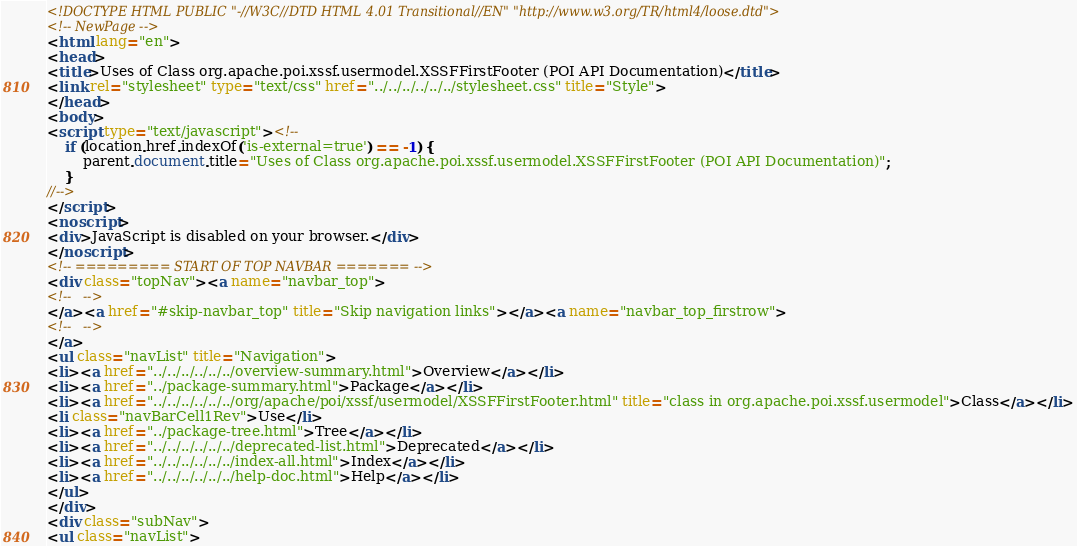<code> <loc_0><loc_0><loc_500><loc_500><_HTML_><!DOCTYPE HTML PUBLIC "-//W3C//DTD HTML 4.01 Transitional//EN" "http://www.w3.org/TR/html4/loose.dtd">
<!-- NewPage -->
<html lang="en">
<head>
<title>Uses of Class org.apache.poi.xssf.usermodel.XSSFFirstFooter (POI API Documentation)</title>
<link rel="stylesheet" type="text/css" href="../../../../../../stylesheet.css" title="Style">
</head>
<body>
<script type="text/javascript"><!--
    if (location.href.indexOf('is-external=true') == -1) {
        parent.document.title="Uses of Class org.apache.poi.xssf.usermodel.XSSFFirstFooter (POI API Documentation)";
    }
//-->
</script>
<noscript>
<div>JavaScript is disabled on your browser.</div>
</noscript>
<!-- ========= START OF TOP NAVBAR ======= -->
<div class="topNav"><a name="navbar_top">
<!--   -->
</a><a href="#skip-navbar_top" title="Skip navigation links"></a><a name="navbar_top_firstrow">
<!--   -->
</a>
<ul class="navList" title="Navigation">
<li><a href="../../../../../../overview-summary.html">Overview</a></li>
<li><a href="../package-summary.html">Package</a></li>
<li><a href="../../../../../../org/apache/poi/xssf/usermodel/XSSFFirstFooter.html" title="class in org.apache.poi.xssf.usermodel">Class</a></li>
<li class="navBarCell1Rev">Use</li>
<li><a href="../package-tree.html">Tree</a></li>
<li><a href="../../../../../../deprecated-list.html">Deprecated</a></li>
<li><a href="../../../../../../index-all.html">Index</a></li>
<li><a href="../../../../../../help-doc.html">Help</a></li>
</ul>
</div>
<div class="subNav">
<ul class="navList"></code> 